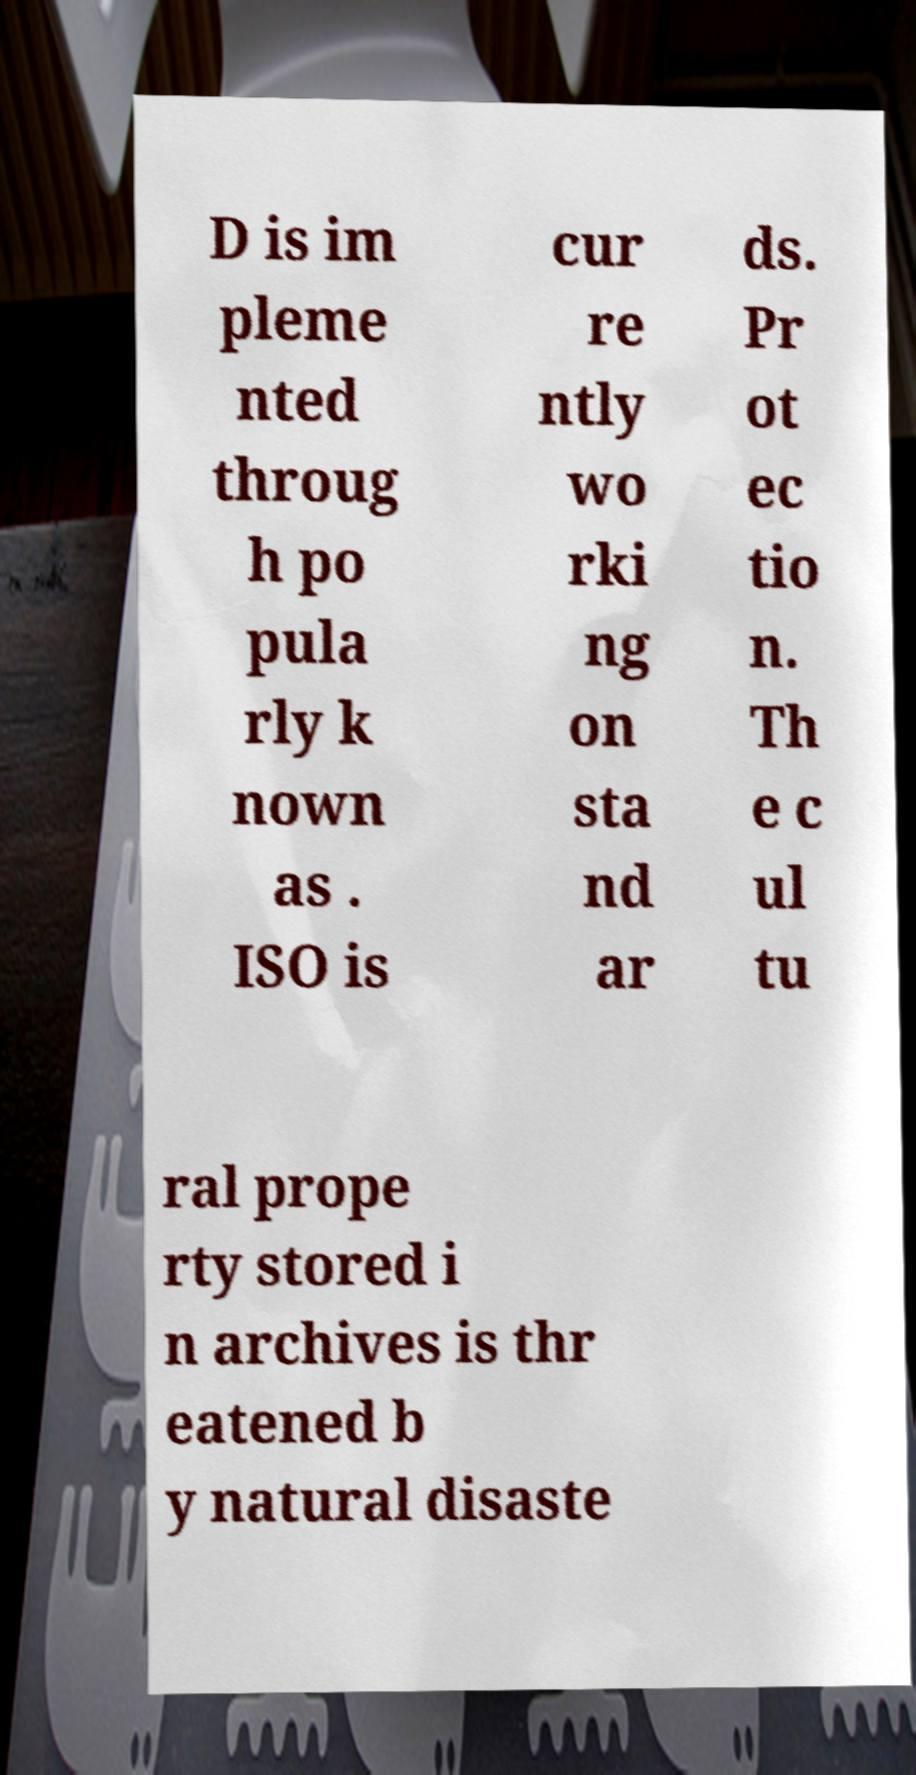For documentation purposes, I need the text within this image transcribed. Could you provide that? D is im pleme nted throug h po pula rly k nown as . ISO is cur re ntly wo rki ng on sta nd ar ds. Pr ot ec tio n. Th e c ul tu ral prope rty stored i n archives is thr eatened b y natural disaste 